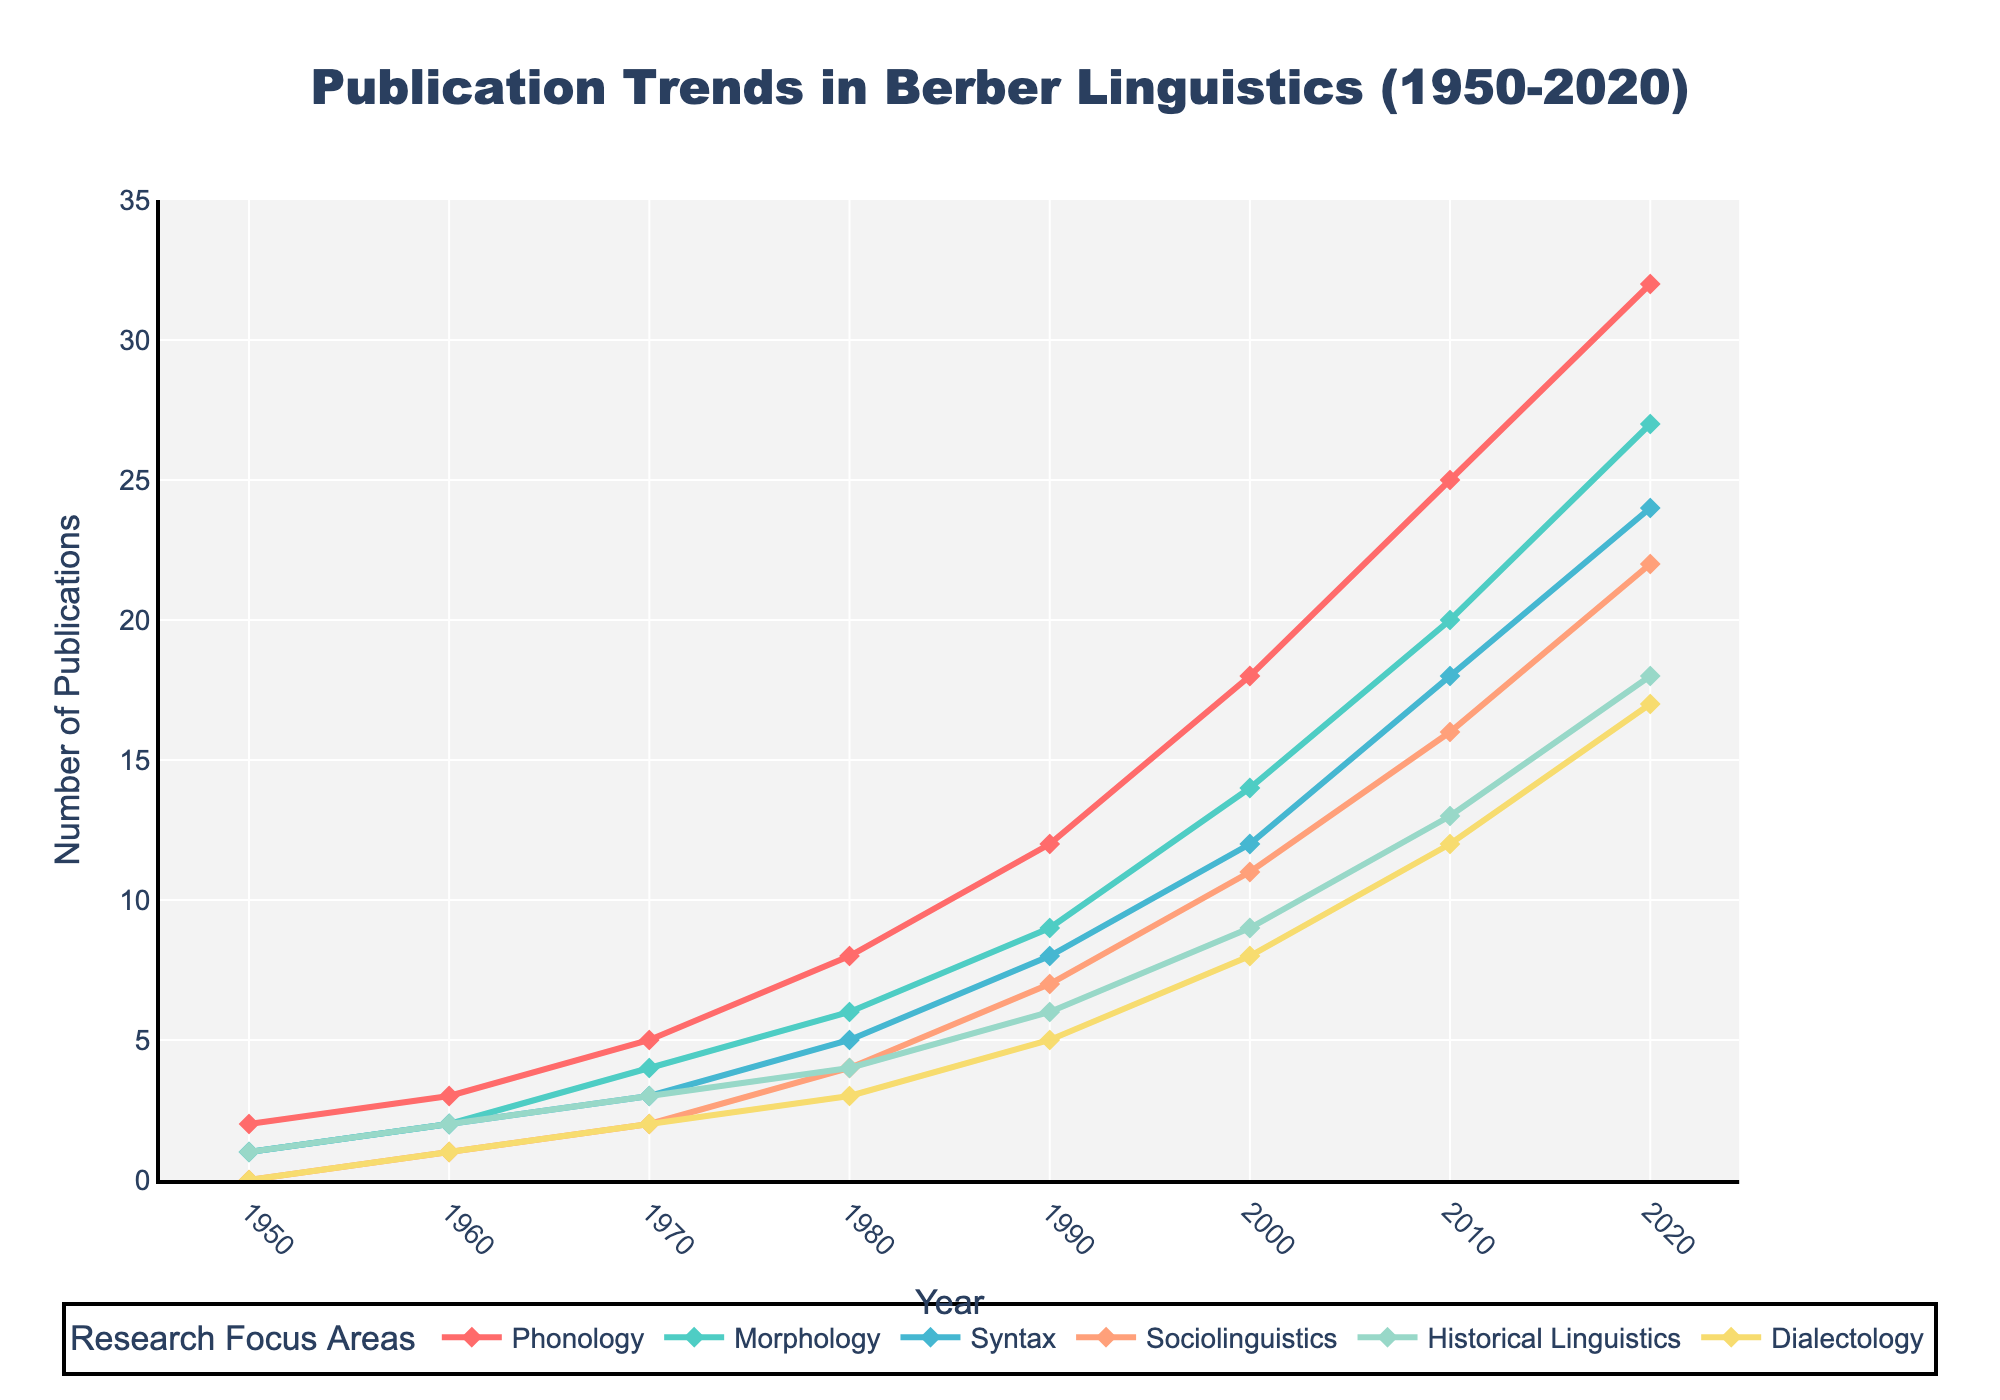What is the general trend of publications in Berber linguistics from 1950 to 2020? The general trend shows a steady increase in the number of publications across all focus areas over the years. This is reflected in the consistent upward trajectories of the lines for each focus area in the plot.
Answer: Steady increase Which research focus area had the highest number of publications in 2020? By looking at the lines in the plot, the 'Phonology' line reaches the highest point in 2020, indicating that this area had the most publications.
Answer: Phonology How do the number of publications in Syntax and Sociolinguistics in 1970 compare? In 1970, the publication numbers for Syntax and Sociolinguistics can be identified from their respective lines. Syntax had 3 publications and Sociolinguistics had 2 publications. Therefore, Syntax had more publications than Sociolinguistics in that year.
Answer: Syntax: 3, Sociolinguistics: 2 What is the sum of publications for Phonology and Morphology in 1990? Referring to the plotted lines for Phonology and Morphology in 1990, Phonology had 12 and Morphology had 9 publications. The sum of these is 12 + 9 = 21.
Answer: 21 Which focus area consistently had the lowest number of publications until 1980? Observing the trend lines, 'Dialectology' had the lowest number of publications consistently, as its line is at or near the bottom until 1980.
Answer: Dialectology In which decade did Historical Linguistics see the biggest increase in publications, and by how much? Comparing the year-on-year differences in the Historical Linguistics line, the biggest increase is from 1990 to 2000, where the number went from 6 to 9, resulting in an increase of 3 publications.
Answer: 1990-2000, by 3 What is the combined total of publications for all focus areas in 2000? Summing the values for each focus area in 2000: Phonology (18) + Morphology (14) + Syntax (12) + Sociolinguistics (11) + Historical Linguistics (9) + Dialectology (8) = 72.
Answer: 72 How does the number of publications in Dialectology in 1980 compare to that in 2020? In 1980, Dialectology had 3 publications and in 2020 it had 17. Comparing these, the number significantly increased by 14 publications over the 40 years.
Answer: 1980: 3, 2020: 17 What is the median number of publications for the area with the highest publications in 2020 across all years? For Phonology, the publication numbers over the years are [2, 3, 5, 8, 12, 18, 25, 32]. To find the median, we arrange and find the middle value(s). Here, the middle values are 8 and 12, so the median is (8+12)/2 = 10.
Answer: 10 Which two focus areas had the closest number of publications to each other in 2010? In 2010, checking the values for each focus area, Syntax (18) and Sociolinguistics (16) were the closest, having only a difference of 2 publications.
Answer: Syntax and Sociolinguistics 